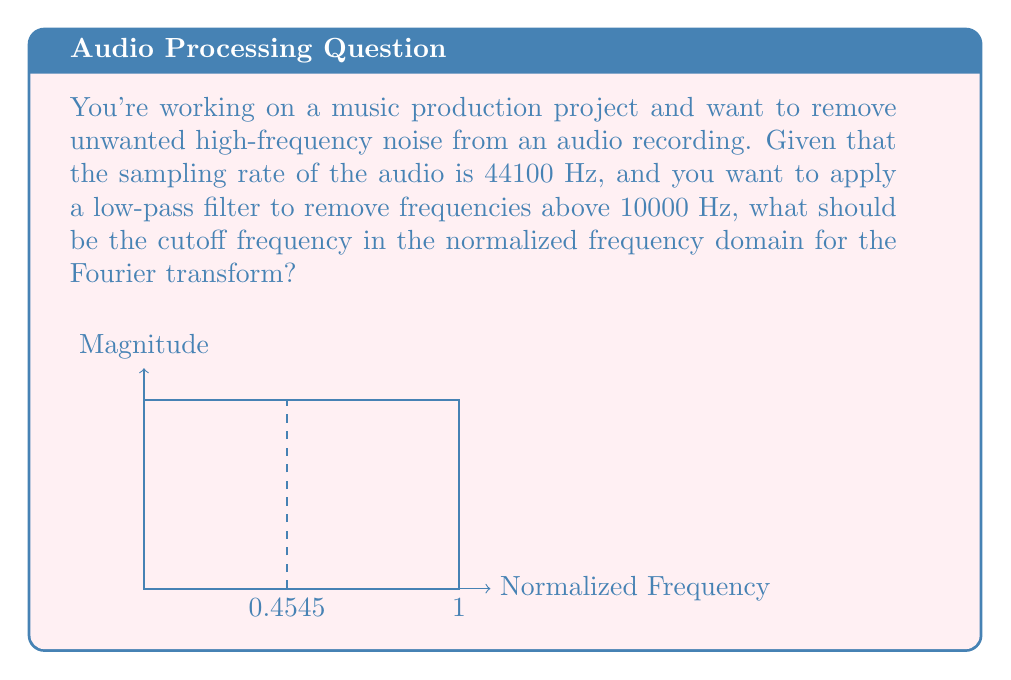What is the answer to this math problem? To solve this problem, we need to follow these steps:

1) First, recall that the Nyquist frequency is half the sampling rate. This is the highest frequency that can be represented in the digital signal. 
   $$f_{Nyquist} = \frac{f_{sampling}}{2} = \frac{44100}{2} = 22050 \text{ Hz}$$

2) In the normalized frequency domain, frequencies range from 0 to 1, where 1 corresponds to the Nyquist frequency.

3) We want to find where 10000 Hz falls in this normalized range. We can set up a proportion:
   $$\frac{10000}{22050} = \frac{x}{1}$$

4) Solve for x:
   $$x = \frac{10000}{22050} \approx 0.4545$$

5) This means that in the normalized frequency domain, a frequency of 10000 Hz corresponds to approximately 0.4545.

6) Therefore, to remove frequencies above 10000 Hz, we should set our low-pass filter cutoff at 0.4545 in the normalized frequency domain.
Answer: 0.4545 